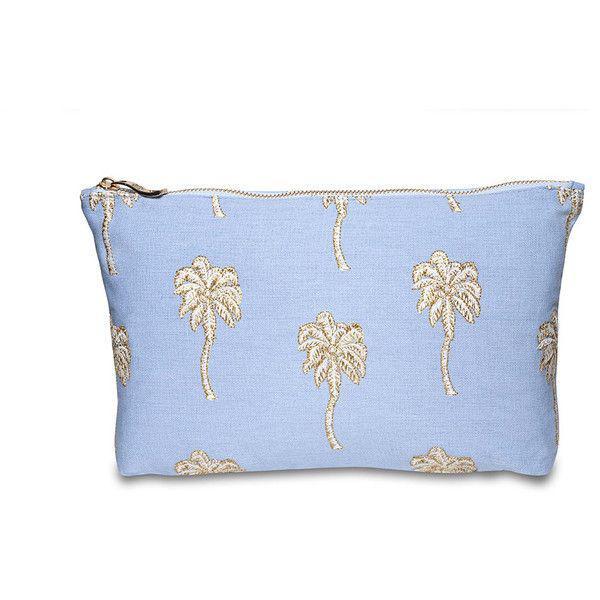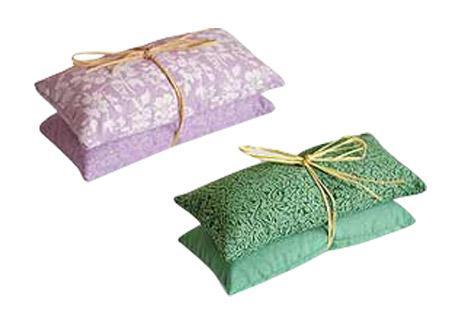The first image is the image on the left, the second image is the image on the right. Analyze the images presented: Is the assertion "One image features one square pillow decorated with flowers, and the other image features at least one fabric item decorated with sprigs of lavender." valid? Answer yes or no. No. 